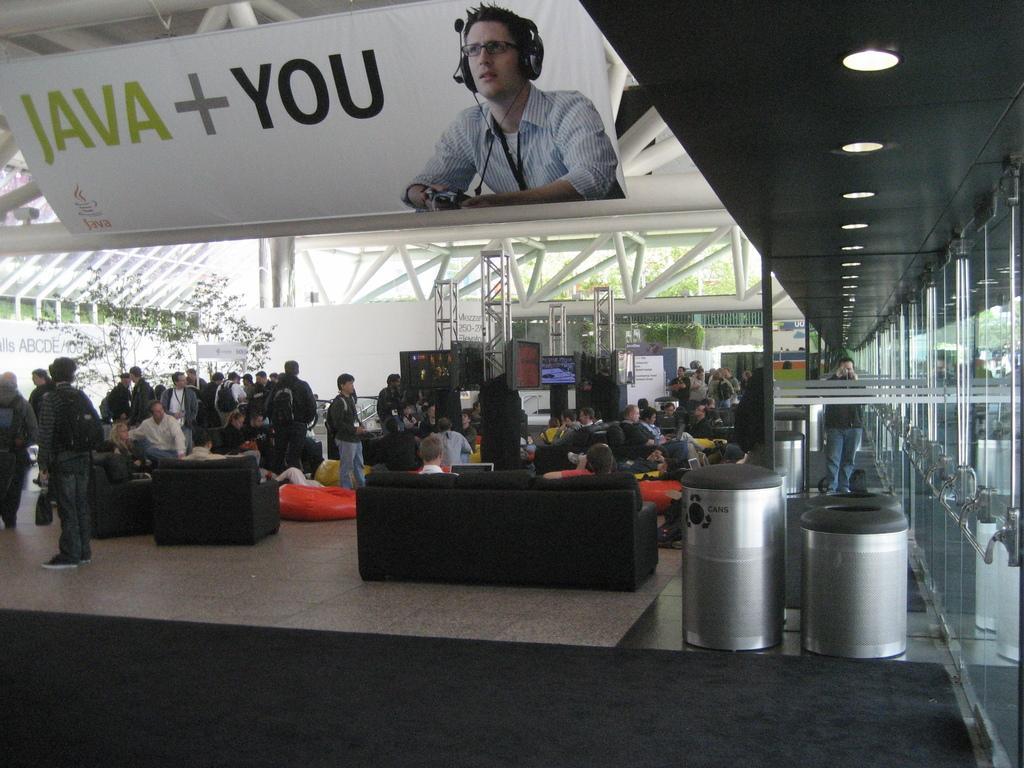Describe this image in one or two sentences. In this image in front there is a mat on the floor. There are people sitting on the sofa and there are few other people standing on the floor. On the right side of the image there are dustbins. There are glass doors. In the background of the image there are TVs. There are trees. On top of the image there are lights. There is a banner. 